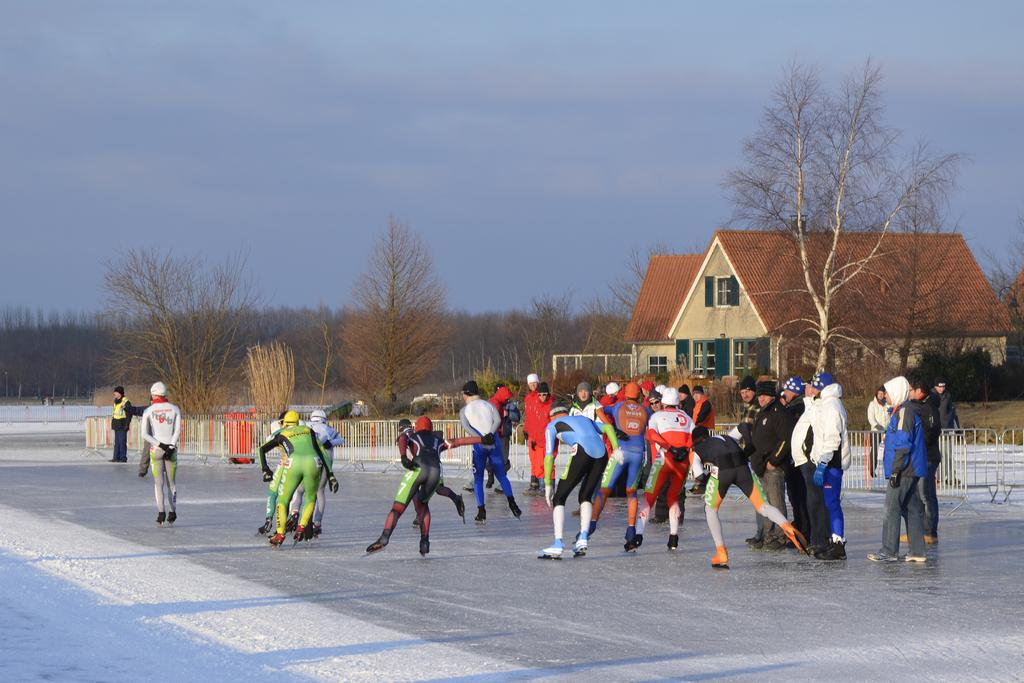How many people are in the image? There are people in the image, but the exact number is not specified. What type of pathway is present in the image? There is a road in the image. What is the weather like in the image? There is snow in the image, indicating a cold or wintry environment. What type of barrier is present in the image? There is a fence and barricades in the image. What type of building is present in the image? There is a house in the image. What type of vegetation is present in the image? There are trees and grass in the image. What is visible in the background of the image? The sky is visible in the background of the image. What type of game is being played in the image? There is no game being played in the image; it features people, a road, snow, a fence, barricades, a house, trees, grass, and the sky. How does the snow help the nerves of the people in the image? There is no mention of nerves or any connection between the snow and the people's nerves in the image. 